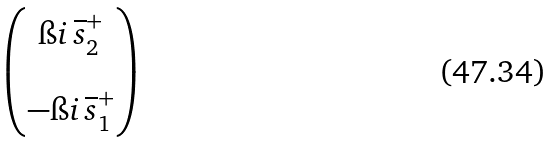<formula> <loc_0><loc_0><loc_500><loc_500>\begin{pmatrix} \i i \, \overline { s } ^ { + } _ { 2 } \\ \\ - \i i \, \overline { s } ^ { + } _ { 1 } \end{pmatrix}</formula> 